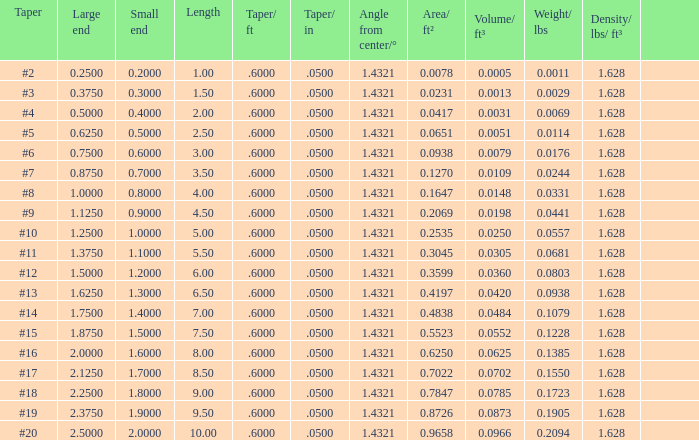Which Large end has a Taper/ft smaller than 0.6000000000000001? 19.0. 